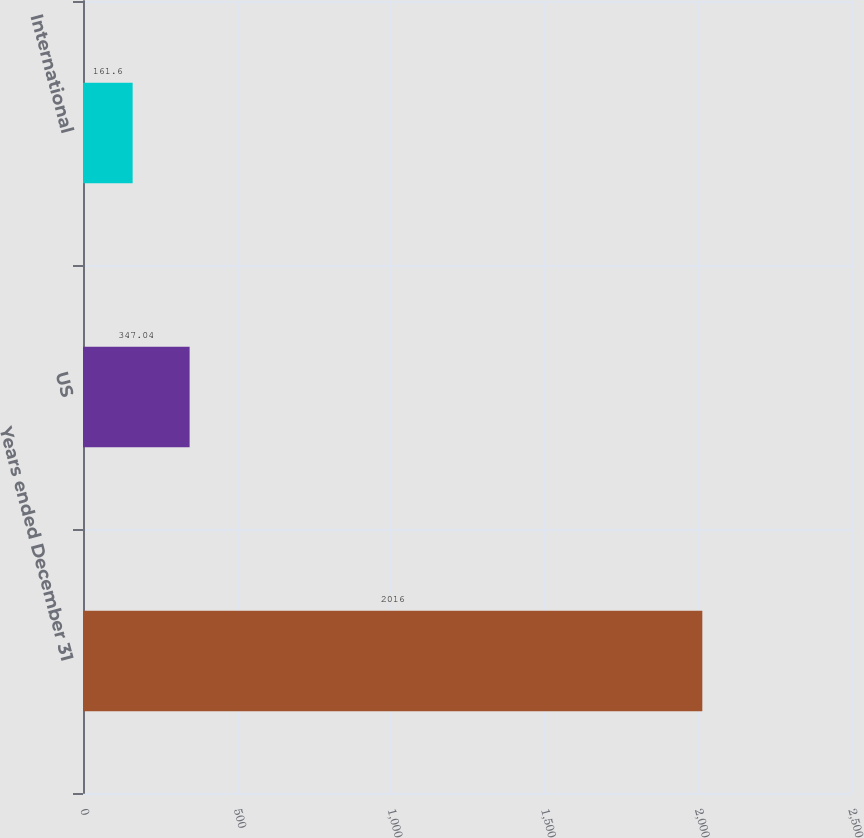Convert chart. <chart><loc_0><loc_0><loc_500><loc_500><bar_chart><fcel>Years ended December 31<fcel>US<fcel>International<nl><fcel>2016<fcel>347.04<fcel>161.6<nl></chart> 